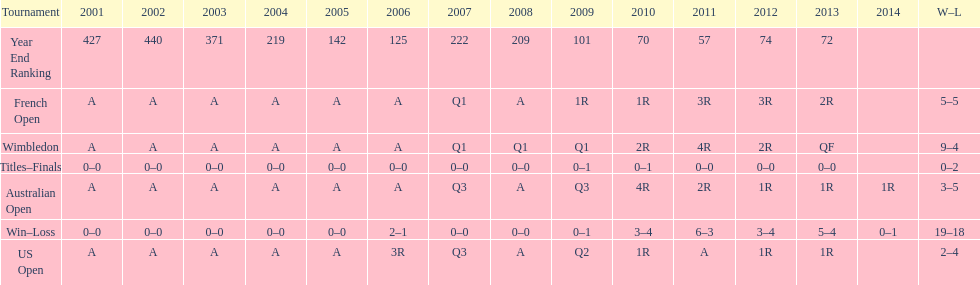What tournament has 5-5 as it's "w-l" record? French Open. 